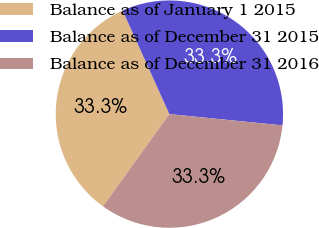<chart> <loc_0><loc_0><loc_500><loc_500><pie_chart><fcel>Balance as of January 1 2015<fcel>Balance as of December 31 2015<fcel>Balance as of December 31 2016<nl><fcel>33.33%<fcel>33.33%<fcel>33.34%<nl></chart> 